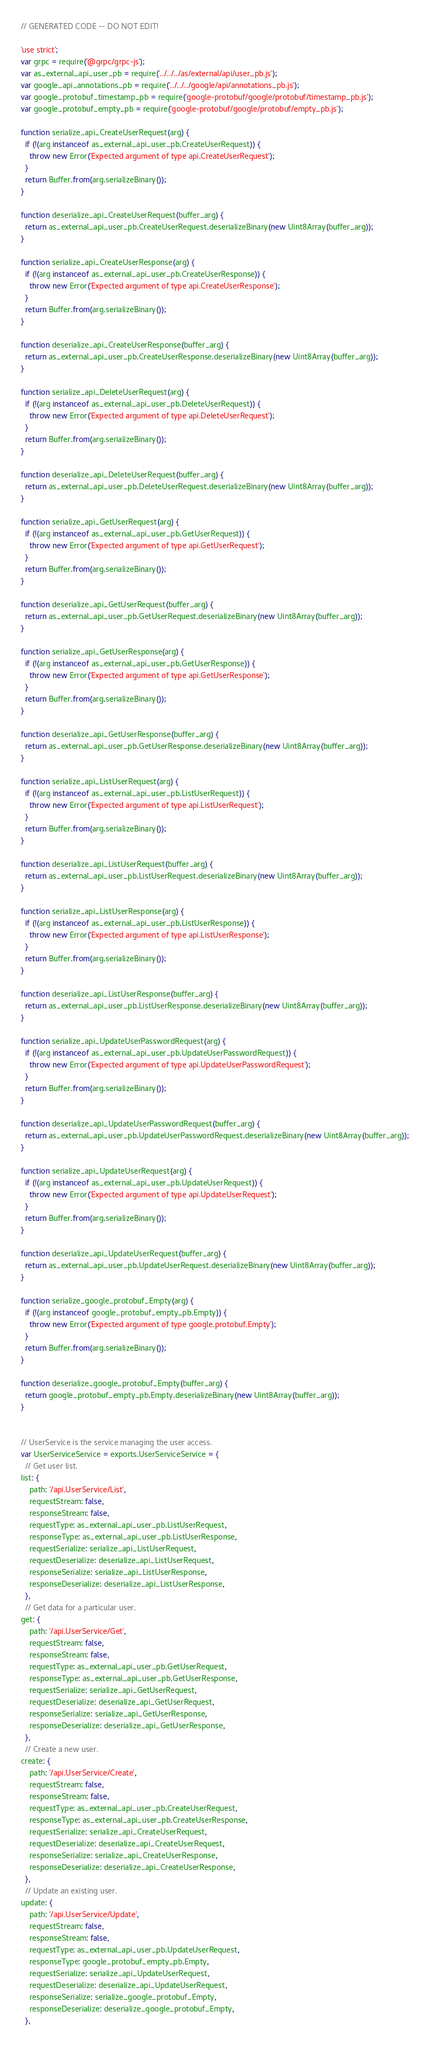<code> <loc_0><loc_0><loc_500><loc_500><_JavaScript_>// GENERATED CODE -- DO NOT EDIT!

'use strict';
var grpc = require('@grpc/grpc-js');
var as_external_api_user_pb = require('../../../as/external/api/user_pb.js');
var google_api_annotations_pb = require('../../../google/api/annotations_pb.js');
var google_protobuf_timestamp_pb = require('google-protobuf/google/protobuf/timestamp_pb.js');
var google_protobuf_empty_pb = require('google-protobuf/google/protobuf/empty_pb.js');

function serialize_api_CreateUserRequest(arg) {
  if (!(arg instanceof as_external_api_user_pb.CreateUserRequest)) {
    throw new Error('Expected argument of type api.CreateUserRequest');
  }
  return Buffer.from(arg.serializeBinary());
}

function deserialize_api_CreateUserRequest(buffer_arg) {
  return as_external_api_user_pb.CreateUserRequest.deserializeBinary(new Uint8Array(buffer_arg));
}

function serialize_api_CreateUserResponse(arg) {
  if (!(arg instanceof as_external_api_user_pb.CreateUserResponse)) {
    throw new Error('Expected argument of type api.CreateUserResponse');
  }
  return Buffer.from(arg.serializeBinary());
}

function deserialize_api_CreateUserResponse(buffer_arg) {
  return as_external_api_user_pb.CreateUserResponse.deserializeBinary(new Uint8Array(buffer_arg));
}

function serialize_api_DeleteUserRequest(arg) {
  if (!(arg instanceof as_external_api_user_pb.DeleteUserRequest)) {
    throw new Error('Expected argument of type api.DeleteUserRequest');
  }
  return Buffer.from(arg.serializeBinary());
}

function deserialize_api_DeleteUserRequest(buffer_arg) {
  return as_external_api_user_pb.DeleteUserRequest.deserializeBinary(new Uint8Array(buffer_arg));
}

function serialize_api_GetUserRequest(arg) {
  if (!(arg instanceof as_external_api_user_pb.GetUserRequest)) {
    throw new Error('Expected argument of type api.GetUserRequest');
  }
  return Buffer.from(arg.serializeBinary());
}

function deserialize_api_GetUserRequest(buffer_arg) {
  return as_external_api_user_pb.GetUserRequest.deserializeBinary(new Uint8Array(buffer_arg));
}

function serialize_api_GetUserResponse(arg) {
  if (!(arg instanceof as_external_api_user_pb.GetUserResponse)) {
    throw new Error('Expected argument of type api.GetUserResponse');
  }
  return Buffer.from(arg.serializeBinary());
}

function deserialize_api_GetUserResponse(buffer_arg) {
  return as_external_api_user_pb.GetUserResponse.deserializeBinary(new Uint8Array(buffer_arg));
}

function serialize_api_ListUserRequest(arg) {
  if (!(arg instanceof as_external_api_user_pb.ListUserRequest)) {
    throw new Error('Expected argument of type api.ListUserRequest');
  }
  return Buffer.from(arg.serializeBinary());
}

function deserialize_api_ListUserRequest(buffer_arg) {
  return as_external_api_user_pb.ListUserRequest.deserializeBinary(new Uint8Array(buffer_arg));
}

function serialize_api_ListUserResponse(arg) {
  if (!(arg instanceof as_external_api_user_pb.ListUserResponse)) {
    throw new Error('Expected argument of type api.ListUserResponse');
  }
  return Buffer.from(arg.serializeBinary());
}

function deserialize_api_ListUserResponse(buffer_arg) {
  return as_external_api_user_pb.ListUserResponse.deserializeBinary(new Uint8Array(buffer_arg));
}

function serialize_api_UpdateUserPasswordRequest(arg) {
  if (!(arg instanceof as_external_api_user_pb.UpdateUserPasswordRequest)) {
    throw new Error('Expected argument of type api.UpdateUserPasswordRequest');
  }
  return Buffer.from(arg.serializeBinary());
}

function deserialize_api_UpdateUserPasswordRequest(buffer_arg) {
  return as_external_api_user_pb.UpdateUserPasswordRequest.deserializeBinary(new Uint8Array(buffer_arg));
}

function serialize_api_UpdateUserRequest(arg) {
  if (!(arg instanceof as_external_api_user_pb.UpdateUserRequest)) {
    throw new Error('Expected argument of type api.UpdateUserRequest');
  }
  return Buffer.from(arg.serializeBinary());
}

function deserialize_api_UpdateUserRequest(buffer_arg) {
  return as_external_api_user_pb.UpdateUserRequest.deserializeBinary(new Uint8Array(buffer_arg));
}

function serialize_google_protobuf_Empty(arg) {
  if (!(arg instanceof google_protobuf_empty_pb.Empty)) {
    throw new Error('Expected argument of type google.protobuf.Empty');
  }
  return Buffer.from(arg.serializeBinary());
}

function deserialize_google_protobuf_Empty(buffer_arg) {
  return google_protobuf_empty_pb.Empty.deserializeBinary(new Uint8Array(buffer_arg));
}


// UserService is the service managing the user access.
var UserServiceService = exports.UserServiceService = {
  // Get user list.
list: {
    path: '/api.UserService/List',
    requestStream: false,
    responseStream: false,
    requestType: as_external_api_user_pb.ListUserRequest,
    responseType: as_external_api_user_pb.ListUserResponse,
    requestSerialize: serialize_api_ListUserRequest,
    requestDeserialize: deserialize_api_ListUserRequest,
    responseSerialize: serialize_api_ListUserResponse,
    responseDeserialize: deserialize_api_ListUserResponse,
  },
  // Get data for a particular user.
get: {
    path: '/api.UserService/Get',
    requestStream: false,
    responseStream: false,
    requestType: as_external_api_user_pb.GetUserRequest,
    responseType: as_external_api_user_pb.GetUserResponse,
    requestSerialize: serialize_api_GetUserRequest,
    requestDeserialize: deserialize_api_GetUserRequest,
    responseSerialize: serialize_api_GetUserResponse,
    responseDeserialize: deserialize_api_GetUserResponse,
  },
  // Create a new user.
create: {
    path: '/api.UserService/Create',
    requestStream: false,
    responseStream: false,
    requestType: as_external_api_user_pb.CreateUserRequest,
    responseType: as_external_api_user_pb.CreateUserResponse,
    requestSerialize: serialize_api_CreateUserRequest,
    requestDeserialize: deserialize_api_CreateUserRequest,
    responseSerialize: serialize_api_CreateUserResponse,
    responseDeserialize: deserialize_api_CreateUserResponse,
  },
  // Update an existing user.
update: {
    path: '/api.UserService/Update',
    requestStream: false,
    responseStream: false,
    requestType: as_external_api_user_pb.UpdateUserRequest,
    responseType: google_protobuf_empty_pb.Empty,
    requestSerialize: serialize_api_UpdateUserRequest,
    requestDeserialize: deserialize_api_UpdateUserRequest,
    responseSerialize: serialize_google_protobuf_Empty,
    responseDeserialize: deserialize_google_protobuf_Empty,
  },</code> 